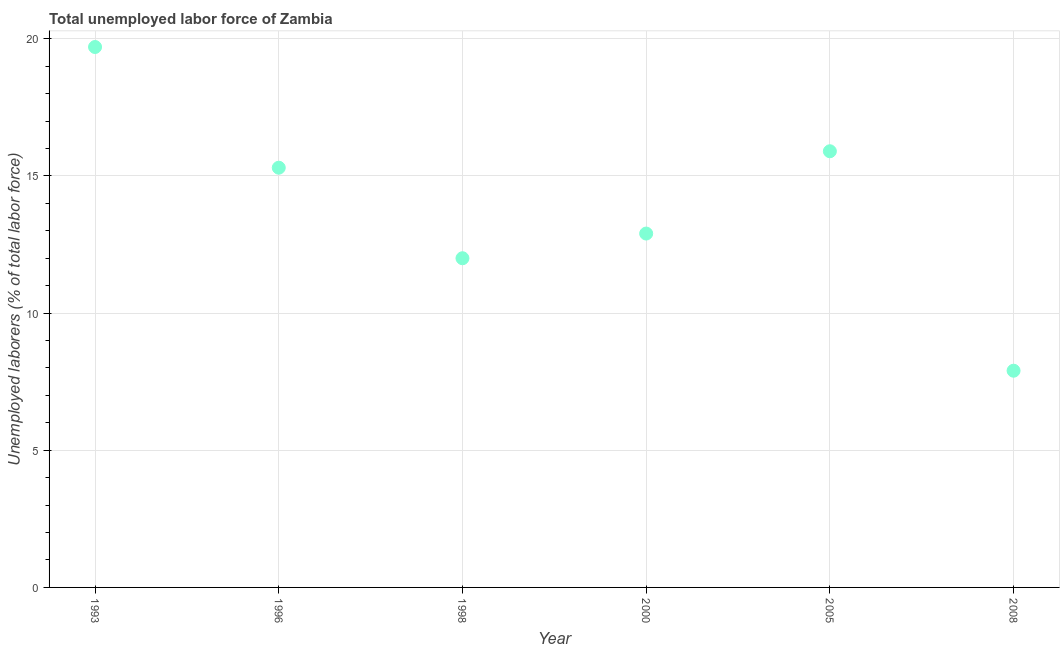Across all years, what is the maximum total unemployed labour force?
Provide a short and direct response. 19.7. Across all years, what is the minimum total unemployed labour force?
Provide a succinct answer. 7.9. What is the sum of the total unemployed labour force?
Make the answer very short. 83.7. What is the difference between the total unemployed labour force in 1993 and 1998?
Ensure brevity in your answer.  7.7. What is the average total unemployed labour force per year?
Keep it short and to the point. 13.95. What is the median total unemployed labour force?
Your answer should be very brief. 14.1. Do a majority of the years between 1996 and 1993 (inclusive) have total unemployed labour force greater than 8 %?
Keep it short and to the point. No. What is the ratio of the total unemployed labour force in 1993 to that in 2000?
Provide a short and direct response. 1.53. Is the difference between the total unemployed labour force in 1996 and 2005 greater than the difference between any two years?
Offer a very short reply. No. What is the difference between the highest and the second highest total unemployed labour force?
Offer a terse response. 3.8. What is the difference between the highest and the lowest total unemployed labour force?
Give a very brief answer. 11.8. Does the total unemployed labour force monotonically increase over the years?
Your answer should be very brief. No. How many dotlines are there?
Offer a terse response. 1. How many years are there in the graph?
Your answer should be very brief. 6. What is the difference between two consecutive major ticks on the Y-axis?
Keep it short and to the point. 5. Are the values on the major ticks of Y-axis written in scientific E-notation?
Your answer should be compact. No. Does the graph contain any zero values?
Provide a short and direct response. No. Does the graph contain grids?
Keep it short and to the point. Yes. What is the title of the graph?
Keep it short and to the point. Total unemployed labor force of Zambia. What is the label or title of the X-axis?
Your response must be concise. Year. What is the label or title of the Y-axis?
Provide a succinct answer. Unemployed laborers (% of total labor force). What is the Unemployed laborers (% of total labor force) in 1993?
Offer a very short reply. 19.7. What is the Unemployed laborers (% of total labor force) in 1996?
Your answer should be compact. 15.3. What is the Unemployed laborers (% of total labor force) in 1998?
Give a very brief answer. 12. What is the Unemployed laborers (% of total labor force) in 2000?
Make the answer very short. 12.9. What is the Unemployed laborers (% of total labor force) in 2005?
Ensure brevity in your answer.  15.9. What is the Unemployed laborers (% of total labor force) in 2008?
Offer a very short reply. 7.9. What is the difference between the Unemployed laborers (% of total labor force) in 1993 and 1996?
Keep it short and to the point. 4.4. What is the difference between the Unemployed laborers (% of total labor force) in 1993 and 1998?
Provide a short and direct response. 7.7. What is the difference between the Unemployed laborers (% of total labor force) in 1993 and 2000?
Make the answer very short. 6.8. What is the difference between the Unemployed laborers (% of total labor force) in 1993 and 2005?
Ensure brevity in your answer.  3.8. What is the difference between the Unemployed laborers (% of total labor force) in 1996 and 2005?
Your answer should be very brief. -0.6. What is the difference between the Unemployed laborers (% of total labor force) in 1998 and 2000?
Provide a short and direct response. -0.9. What is the difference between the Unemployed laborers (% of total labor force) in 1998 and 2005?
Provide a succinct answer. -3.9. What is the difference between the Unemployed laborers (% of total labor force) in 2000 and 2005?
Provide a succinct answer. -3. What is the ratio of the Unemployed laborers (% of total labor force) in 1993 to that in 1996?
Keep it short and to the point. 1.29. What is the ratio of the Unemployed laborers (% of total labor force) in 1993 to that in 1998?
Provide a short and direct response. 1.64. What is the ratio of the Unemployed laborers (% of total labor force) in 1993 to that in 2000?
Keep it short and to the point. 1.53. What is the ratio of the Unemployed laborers (% of total labor force) in 1993 to that in 2005?
Offer a terse response. 1.24. What is the ratio of the Unemployed laborers (% of total labor force) in 1993 to that in 2008?
Offer a very short reply. 2.49. What is the ratio of the Unemployed laborers (% of total labor force) in 1996 to that in 1998?
Provide a short and direct response. 1.27. What is the ratio of the Unemployed laborers (% of total labor force) in 1996 to that in 2000?
Your response must be concise. 1.19. What is the ratio of the Unemployed laborers (% of total labor force) in 1996 to that in 2008?
Make the answer very short. 1.94. What is the ratio of the Unemployed laborers (% of total labor force) in 1998 to that in 2005?
Ensure brevity in your answer.  0.76. What is the ratio of the Unemployed laborers (% of total labor force) in 1998 to that in 2008?
Offer a very short reply. 1.52. What is the ratio of the Unemployed laborers (% of total labor force) in 2000 to that in 2005?
Your answer should be very brief. 0.81. What is the ratio of the Unemployed laborers (% of total labor force) in 2000 to that in 2008?
Your answer should be compact. 1.63. What is the ratio of the Unemployed laborers (% of total labor force) in 2005 to that in 2008?
Provide a short and direct response. 2.01. 